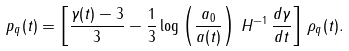Convert formula to latex. <formula><loc_0><loc_0><loc_500><loc_500>p _ { q } ( t ) = \left [ \frac { \gamma ( t ) - 3 } { 3 } - \frac { 1 } { 3 } \log \left ( \frac { a _ { 0 } } { a ( t ) } \right ) \, H ^ { - 1 } \, \frac { d \gamma } { d t } \right ] \, \rho _ { q } ( t ) .</formula> 